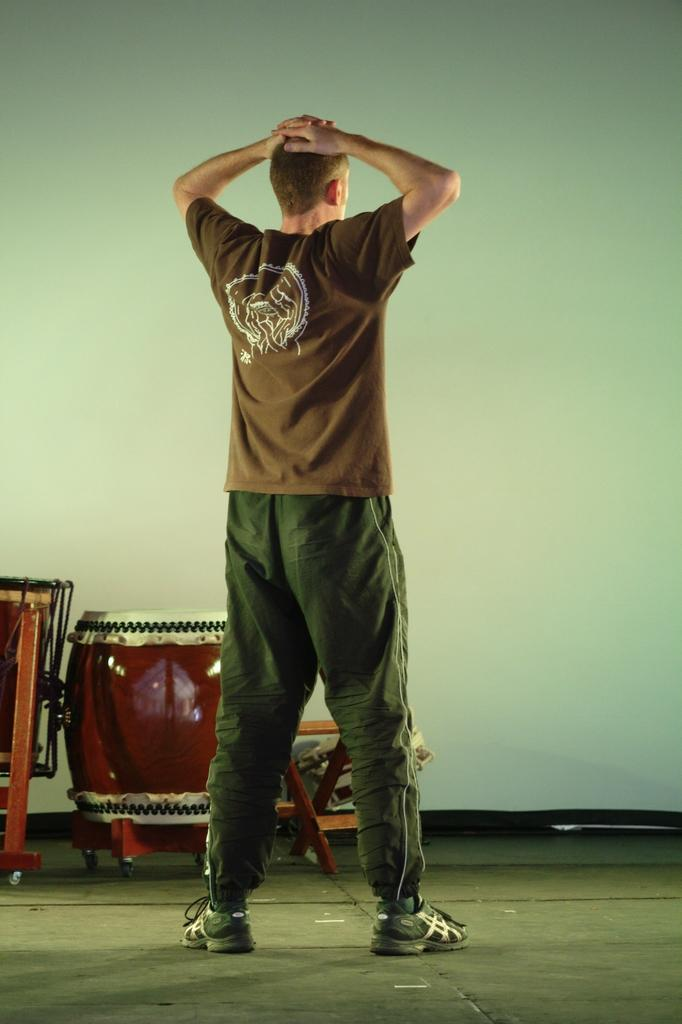What is the main subject of the image? There is a person standing in the image. What is the person wearing on their feet? The person is wearing shoes. What objects are in front of the person? There are musical instruments in front of the person. What can be seen behind the person? There is a wall visible in the image. How many beds are visible in the image? There are no beds present in the image. What type of canvas is being used by the person in the image? There is no canvas visible in the image, nor is the person using one. 